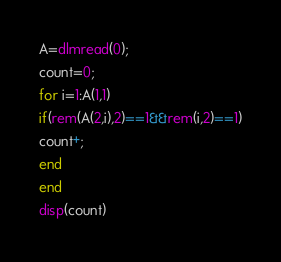<code> <loc_0><loc_0><loc_500><loc_500><_Octave_>A=dlmread(0);
count=0;
for i=1:A(1,1)
if(rem(A(2,i),2)==1&&rem(i,2)==1)
count+;
end
end
disp(count)
</code> 